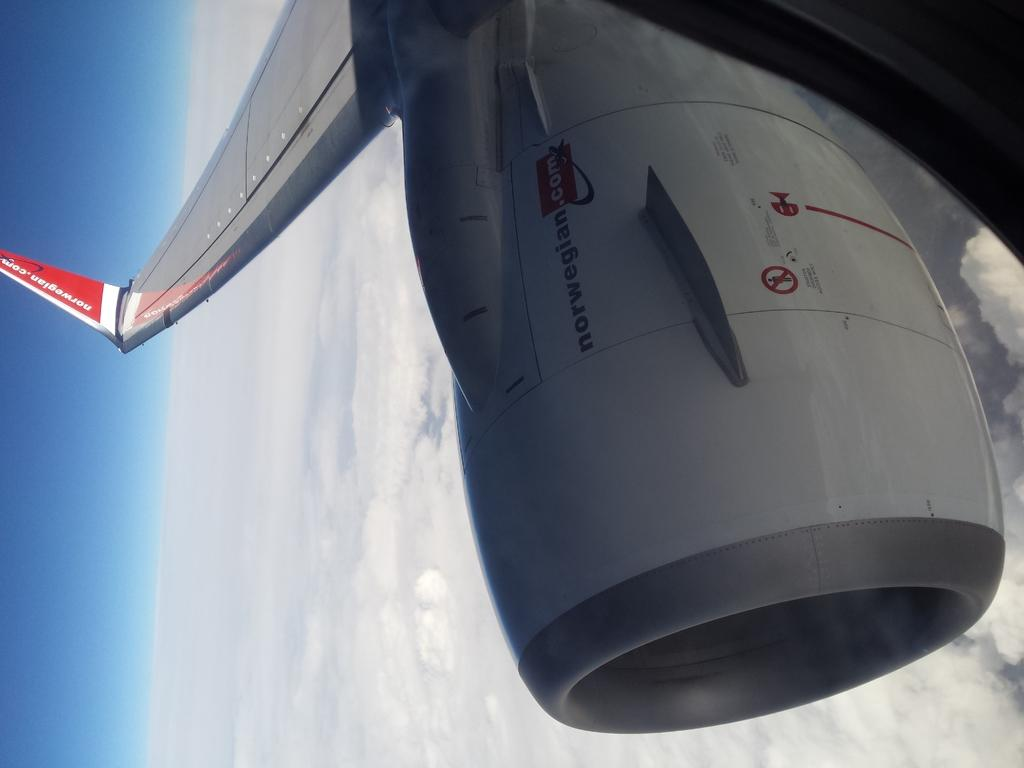<image>
Describe the image concisely. A plane flying above the clouds with norwegian.com on its tail and engine 